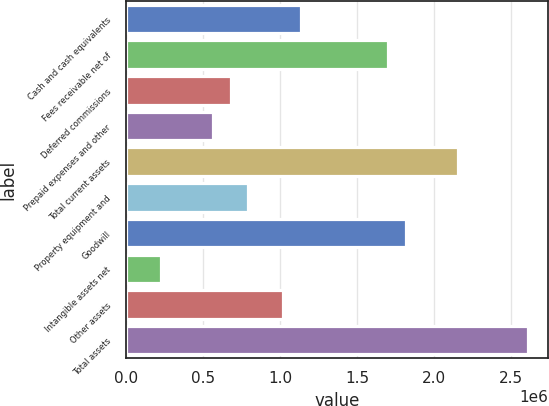Convert chart. <chart><loc_0><loc_0><loc_500><loc_500><bar_chart><fcel>Cash and cash equivalents<fcel>Fees receivable net of<fcel>Deferred commissions<fcel>Prepaid expenses and other<fcel>Total current assets<fcel>Property equipment and<fcel>Goodwill<fcel>Intangible assets net<fcel>Other assets<fcel>Total assets<nl><fcel>1.13321e+06<fcel>1.69978e+06<fcel>679957<fcel>566644<fcel>2.15303e+06<fcel>793270<fcel>1.81309e+06<fcel>226704<fcel>1.0199e+06<fcel>2.60628e+06<nl></chart> 